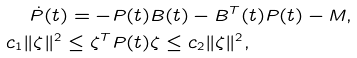<formula> <loc_0><loc_0><loc_500><loc_500>\dot { P } ( t ) = - & P ( t ) B ( t ) - B ^ { T } ( t ) P ( t ) - M , \\ c _ { 1 } \| \zeta \| ^ { 2 } \leq \zeta ^ { T } & P ( t ) \zeta \leq c _ { 2 } \| \zeta \| ^ { 2 } ,</formula> 